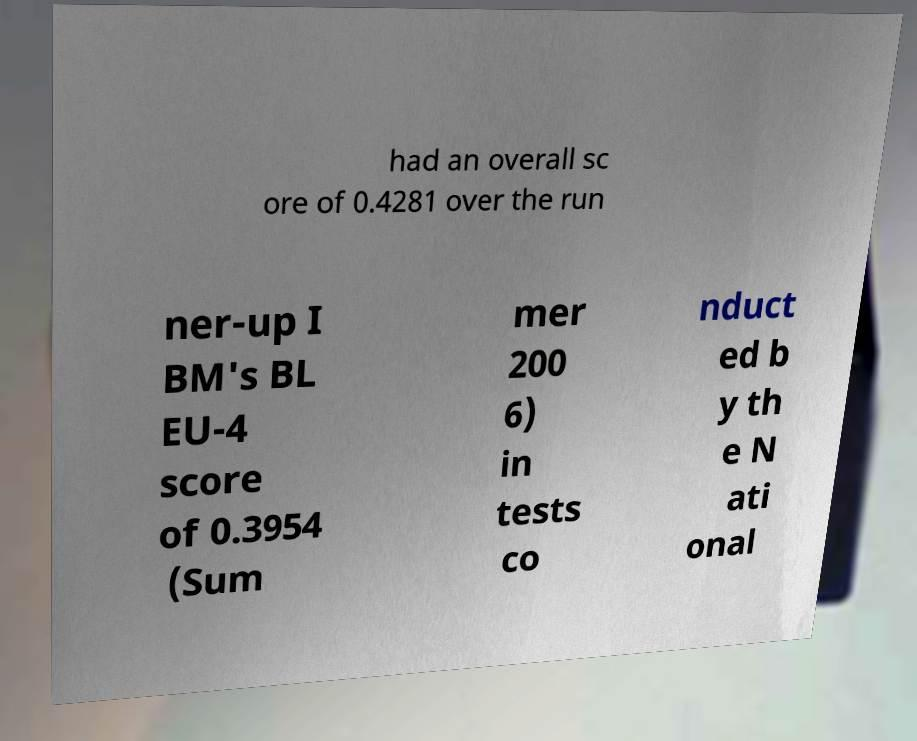Could you assist in decoding the text presented in this image and type it out clearly? had an overall sc ore of 0.4281 over the run ner-up I BM's BL EU-4 score of 0.3954 (Sum mer 200 6) in tests co nduct ed b y th e N ati onal 